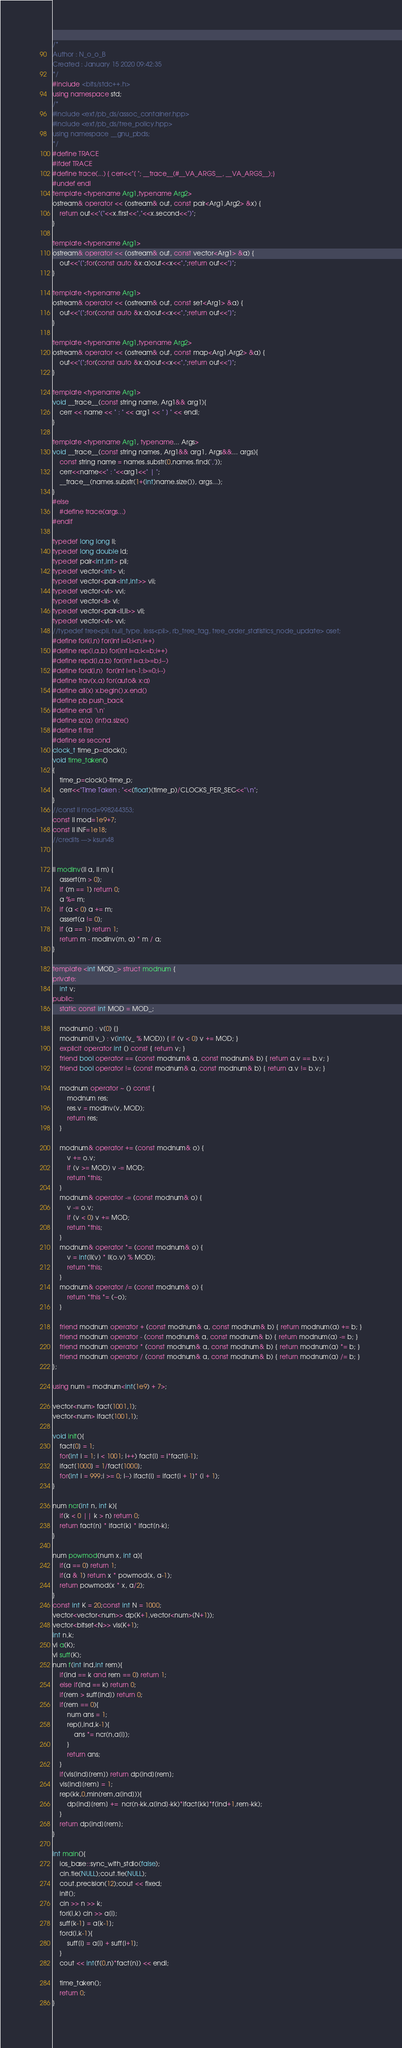<code> <loc_0><loc_0><loc_500><loc_500><_C++_>/*
Author : N_o_o_B
Created : January 15 2020 09:42:35 
*/
#include <bits/stdc++.h>
using namespace std;
/*
#include <ext/pb_ds/assoc_container.hpp>
#include <ext/pb_ds/tree_policy.hpp>
using namespace __gnu_pbds;
*/
#define TRACE
#ifdef TRACE
#define trace(...) { cerr<<"[ "; __trace__(#__VA_ARGS__, __VA_ARGS__);}
#undef endl
template <typename Arg1,typename Arg2>
ostream& operator << (ostream& out, const pair<Arg1,Arg2> &x) {
    return out<<"("<<x.first<<","<<x.second<<")";
}
 
template <typename Arg1>
ostream& operator << (ostream& out, const vector<Arg1> &a) {
    out<<"[";for(const auto &x:a)out<<x<<",";return out<<"]";
}
 
template <typename Arg1>
ostream& operator << (ostream& out, const set<Arg1> &a) {
    out<<"[";for(const auto &x:a)out<<x<<",";return out<<"]";
}
 
template <typename Arg1,typename Arg2>
ostream& operator << (ostream& out, const map<Arg1,Arg2> &a) {
    out<<"[";for(const auto &x:a)out<<x<<",";return out<<"]";
}
 
template <typename Arg1>
void __trace__(const string name, Arg1&& arg1){
    cerr << name << " : " << arg1 << " ] " << endl;
}
 
template <typename Arg1, typename... Args>
void __trace__(const string names, Arg1&& arg1, Args&&... args){
    const string name = names.substr(0,names.find(','));
    cerr<<name<<" : "<<arg1<<" | ";
    __trace__(names.substr(1+(int)name.size()), args...);
}
#else
    #define trace(args...)
#endif
 
typedef long long ll;
typedef long double ld;
typedef pair<int,int> pii;
typedef vector<int> vi;
typedef vector<pair<int,int>> vii;
typedef vector<vi> vvi;
typedef vector<ll> vl;
typedef vector<pair<ll,ll>> vll;
typedef vector<vl> vvl;
//typedef tree<pii, null_type, less<pii>, rb_tree_tag, tree_order_statistics_node_update> oset;
#define fori(i,n) for(int i=0;i<n;i++)
#define rep(i,a,b) for(int i=a;i<=b;i++)
#define repd(i,a,b) for(int i=a;i>=b;i--)
#define ford(i,n)  for(int i=n-1;i>=0;i--)
#define trav(x,a) for(auto& x:a)
#define all(x) x.begin(),x.end()
#define pb push_back
#define endl '\n'
#define sz(a) (int)a.size()
#define fi first
#define se second
clock_t time_p=clock();
void time_taken()
{
    time_p=clock()-time_p;
    cerr<<"Time Taken : "<<(float)(time_p)/CLOCKS_PER_SEC<<"\n";
}
//const ll mod=998244353;
const ll mod=1e9+7;
const ll INF=1e18;
//credits ---> ksun48


ll modinv(ll a, ll m) {
    assert(m > 0);
    if (m == 1) return 0;
    a %= m;
    if (a < 0) a += m;
    assert(a != 0);
    if (a == 1) return 1;
    return m - modinv(m, a) * m / a;
}
 
template <int MOD_> struct modnum {
private:
    int v;
public:
    static const int MOD = MOD_;
 
    modnum() : v(0) {}
    modnum(ll v_) : v(int(v_ % MOD)) { if (v < 0) v += MOD; }
    explicit operator int () const { return v; }
    friend bool operator == (const modnum& a, const modnum& b) { return a.v == b.v; }
    friend bool operator != (const modnum& a, const modnum& b) { return a.v != b.v; }
 
    modnum operator ~ () const {
        modnum res;
        res.v = modinv(v, MOD);
        return res;
    }
 
    modnum& operator += (const modnum& o) {
        v += o.v;
        if (v >= MOD) v -= MOD;
        return *this;
    }
    modnum& operator -= (const modnum& o) {
        v -= o.v;
        if (v < 0) v += MOD;
        return *this;
    }
    modnum& operator *= (const modnum& o) {
        v = int(ll(v) * ll(o.v) % MOD);
        return *this;
    }
    modnum& operator /= (const modnum& o) {
        return *this *= (~o);
    }
 
    friend modnum operator + (const modnum& a, const modnum& b) { return modnum(a) += b; }
    friend modnum operator - (const modnum& a, const modnum& b) { return modnum(a) -= b; }
    friend modnum operator * (const modnum& a, const modnum& b) { return modnum(a) *= b; }
    friend modnum operator / (const modnum& a, const modnum& b) { return modnum(a) /= b; }
};
 
using num = modnum<int(1e9) + 7>;
 
vector<num> fact(1001,1);
vector<num> ifact(1001,1);
 
void init(){
    fact[0] = 1;
    for(int i = 1; i < 1001; i++) fact[i] = i*fact[i-1];
    ifact[1000] = 1/fact[1000];
    for(int i = 999;i >= 0; i--) ifact[i] = ifact[i + 1]* (i + 1);
}
 
num ncr(int n, int k){
    if(k < 0 || k > n) return 0;
    return fact[n] * ifact[k] * ifact[n-k];
}
 
num powmod(num x, int a){
    if(a == 0) return 1;
    if(a & 1) return x * powmod(x, a-1);
    return powmod(x * x, a/2);
}
const int K = 20;const int N = 1000;
vector<vector<num>> dp(K+1,vector<num>(N+1));
vector<bitset<N>> vis(K+1);
int n,k;
vi a(K);
vi suff(K);
num f(int ind,int rem){
    if(ind == k and rem == 0) return 1;
    else if(ind == k) return 0;
    if(rem > suff[ind]) return 0;
    if(rem == 0){
        num ans = 1;
        rep(i,ind,k-1){
            ans *= ncr(n,a[i]);
        }
        return ans;
    }
    if(vis[ind][rem]) return dp[ind][rem];
    vis[ind][rem] = 1;
    rep(kk,0,min(rem,a[ind])){
        dp[ind][rem] +=  ncr(n-kk,a[ind]-kk)*ifact[kk]*f(ind+1,rem-kk);
    }
    return dp[ind][rem];
}

int main(){
    ios_base::sync_with_stdio(false);
    cin.tie(NULL);cout.tie(NULL);
    cout.precision(12);cout << fixed;
    init();
    cin >> n >> k;
    fori(i,k) cin >> a[i];
    suff[k-1] = a[k-1];
    ford(i,k-1){
        suff[i] = a[i] + suff[i+1];
    }
    cout << int(f(0,n)*fact[n]) << endl;

    time_taken();
    return 0;
}</code> 